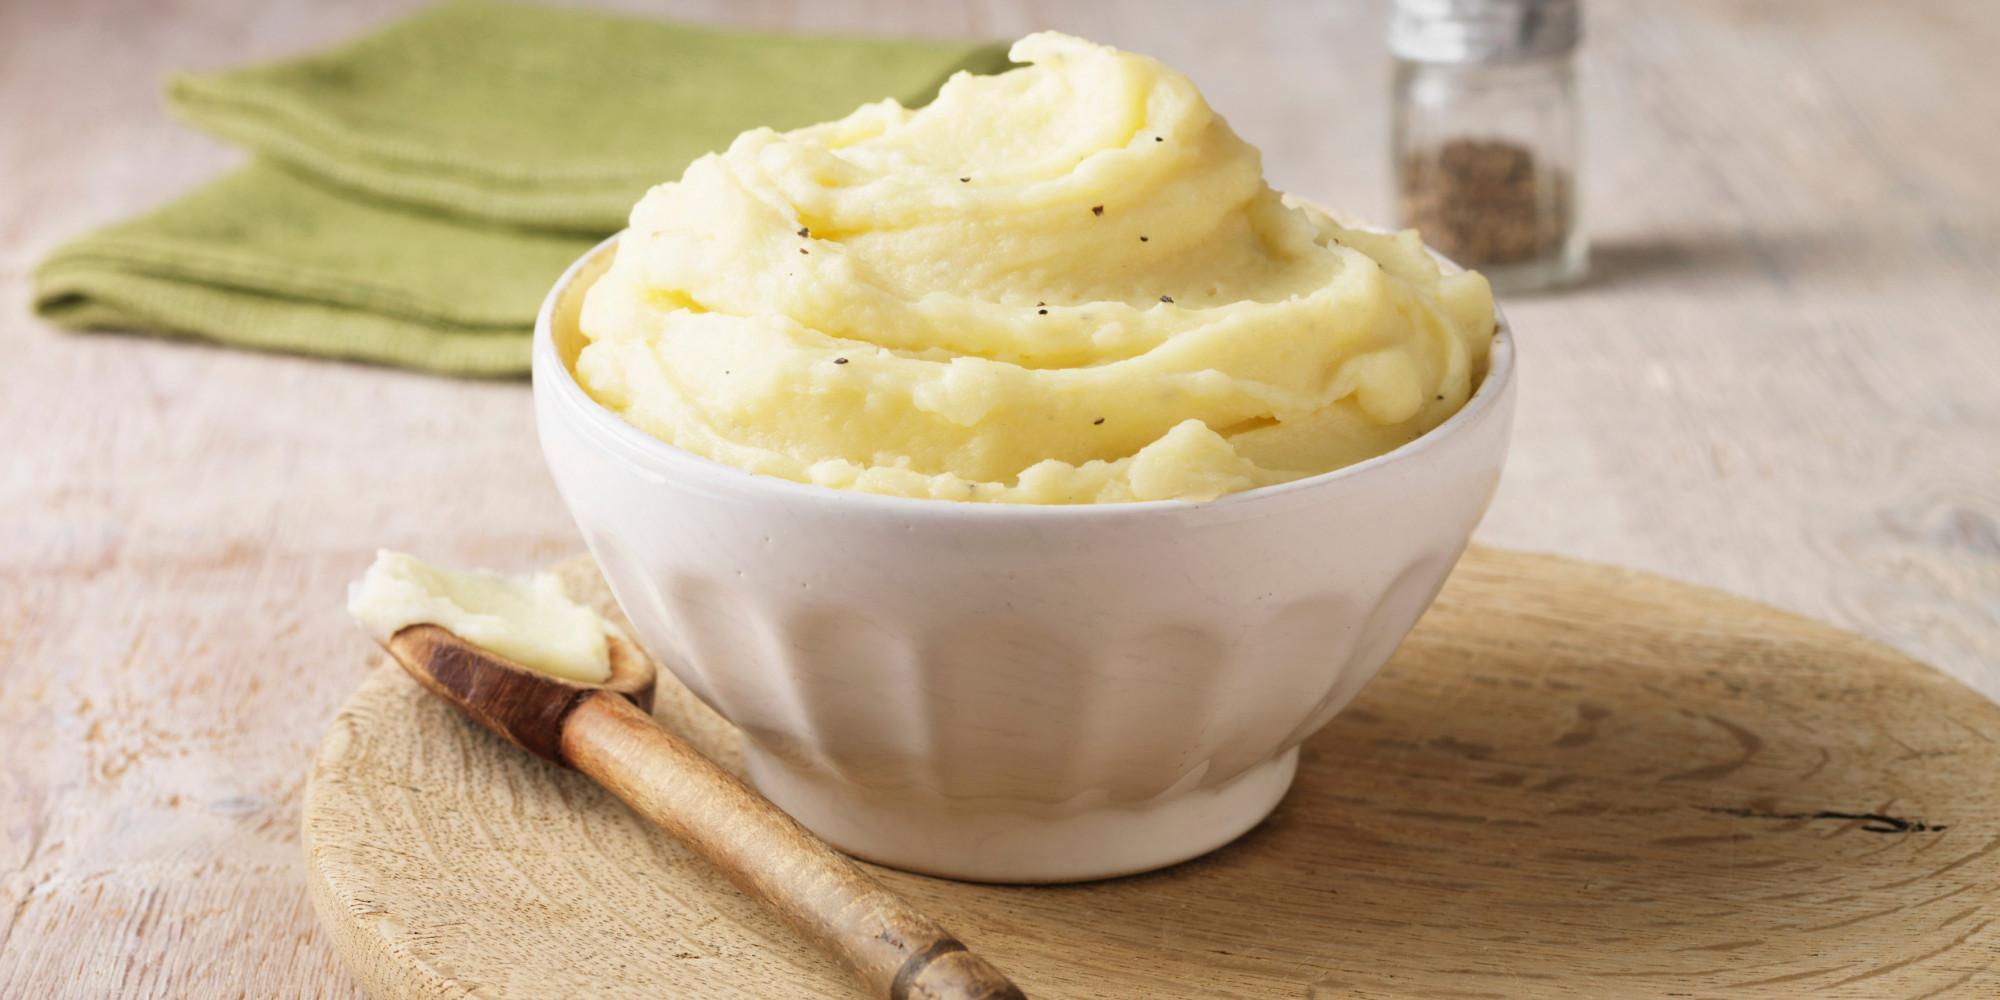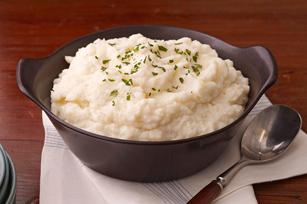The first image is the image on the left, the second image is the image on the right. Assess this claim about the two images: "A white bowl of mashed potato is on top of a round placemat.". Correct or not? Answer yes or no. Yes. The first image is the image on the left, the second image is the image on the right. For the images shown, is this caption "An image shows a piece of silverware on a surface to the right of a bowl of potatoes." true? Answer yes or no. Yes. 